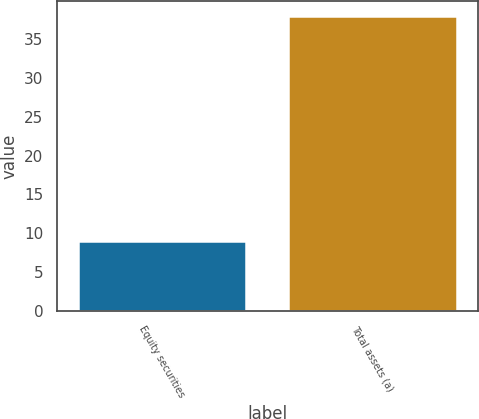Convert chart to OTSL. <chart><loc_0><loc_0><loc_500><loc_500><bar_chart><fcel>Equity securities<fcel>Total assets (a)<nl><fcel>9<fcel>38<nl></chart> 